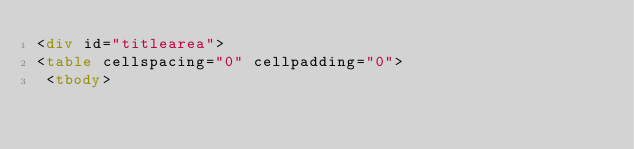<code> <loc_0><loc_0><loc_500><loc_500><_HTML_><div id="titlearea">
<table cellspacing="0" cellpadding="0">
 <tbody></code> 